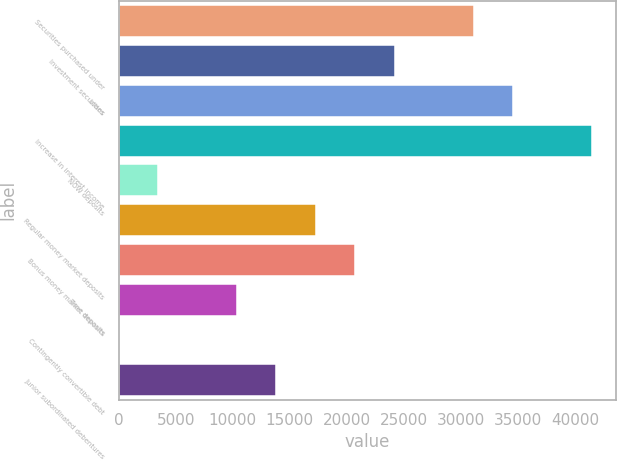Convert chart to OTSL. <chart><loc_0><loc_0><loc_500><loc_500><bar_chart><fcel>Securities purchased under<fcel>Investment securities<fcel>Loans<fcel>Increase in interest income<fcel>NOW deposits<fcel>Regular money market deposits<fcel>Bonus money market deposits<fcel>Time deposits<fcel>Contingently convertible debt<fcel>Junior subordinated debentures<nl><fcel>31099.4<fcel>24190.2<fcel>34554<fcel>41463.2<fcel>3462.6<fcel>17281<fcel>20735.6<fcel>10371.8<fcel>8<fcel>13826.4<nl></chart> 